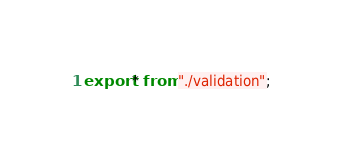Convert code to text. <code><loc_0><loc_0><loc_500><loc_500><_TypeScript_>export * from "./validation";
</code> 